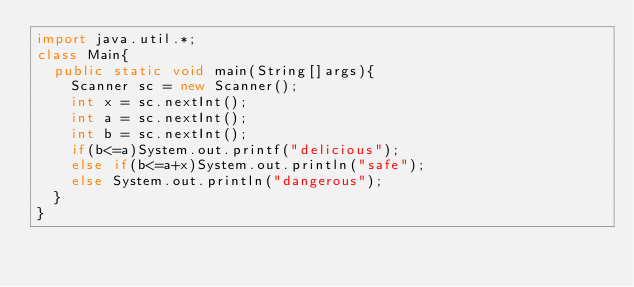<code> <loc_0><loc_0><loc_500><loc_500><_Java_>import java.util.*;
class Main{
  public static void main(String[]args){
    Scanner sc = new Scanner();
    int x = sc.nextInt();
    int a = sc.nextInt();
    int b = sc.nextInt();
    if(b<=a)System.out.printf("delicious");
    else if(b<=a+x)System.out.println("safe");
    else System.out.println("dangerous");
  }
}
</code> 